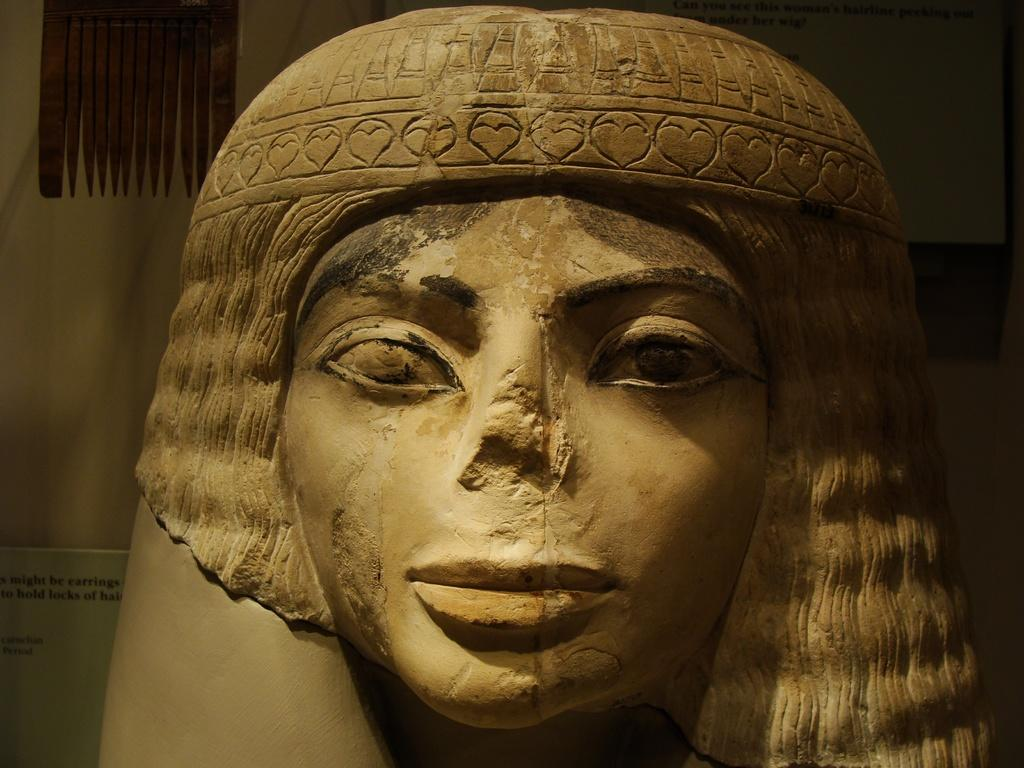What is the main subject of the image? There is a sculpture of a woman in the image. How does the sculpture transport itself to different locations in the image? The sculpture does not transport itself to different locations in the image, as it is a stationary object. 